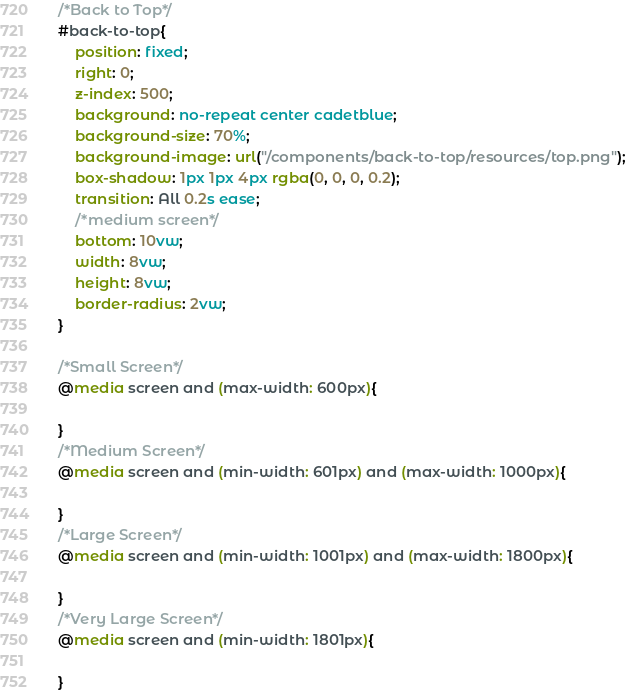<code> <loc_0><loc_0><loc_500><loc_500><_CSS_>/*Back to Top*/
#back-to-top{
    position: fixed;
    right: 0;
    z-index: 500;
    background: no-repeat center cadetblue;
    background-size: 70%;
    background-image: url("/components/back-to-top/resources/top.png");
    box-shadow: 1px 1px 4px rgba(0, 0, 0, 0.2);
    transition: All 0.2s ease;
    /*medium screen*/
    bottom: 10vw;
    width: 8vw;
    height: 8vw;
    border-radius: 2vw;
}

/*Small Screen*/
@media screen and (max-width: 600px){
    
}
/*Medium Screen*/
@media screen and (min-width: 601px) and (max-width: 1000px){
    
}
/*Large Screen*/
@media screen and (min-width: 1001px) and (max-width: 1800px){
    
}
/*Very Large Screen*/
@media screen and (min-width: 1801px){
    
}</code> 